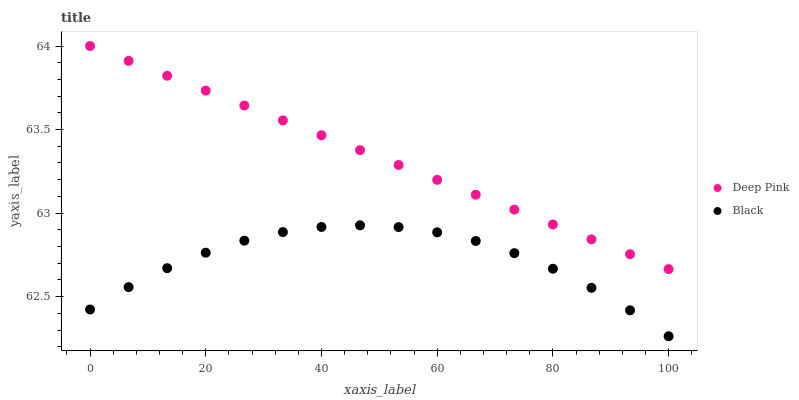Does Black have the minimum area under the curve?
Answer yes or no. Yes. Does Deep Pink have the maximum area under the curve?
Answer yes or no. Yes. Does Black have the maximum area under the curve?
Answer yes or no. No. Is Deep Pink the smoothest?
Answer yes or no. Yes. Is Black the roughest?
Answer yes or no. Yes. Is Black the smoothest?
Answer yes or no. No. Does Black have the lowest value?
Answer yes or no. Yes. Does Deep Pink have the highest value?
Answer yes or no. Yes. Does Black have the highest value?
Answer yes or no. No. Is Black less than Deep Pink?
Answer yes or no. Yes. Is Deep Pink greater than Black?
Answer yes or no. Yes. Does Black intersect Deep Pink?
Answer yes or no. No. 